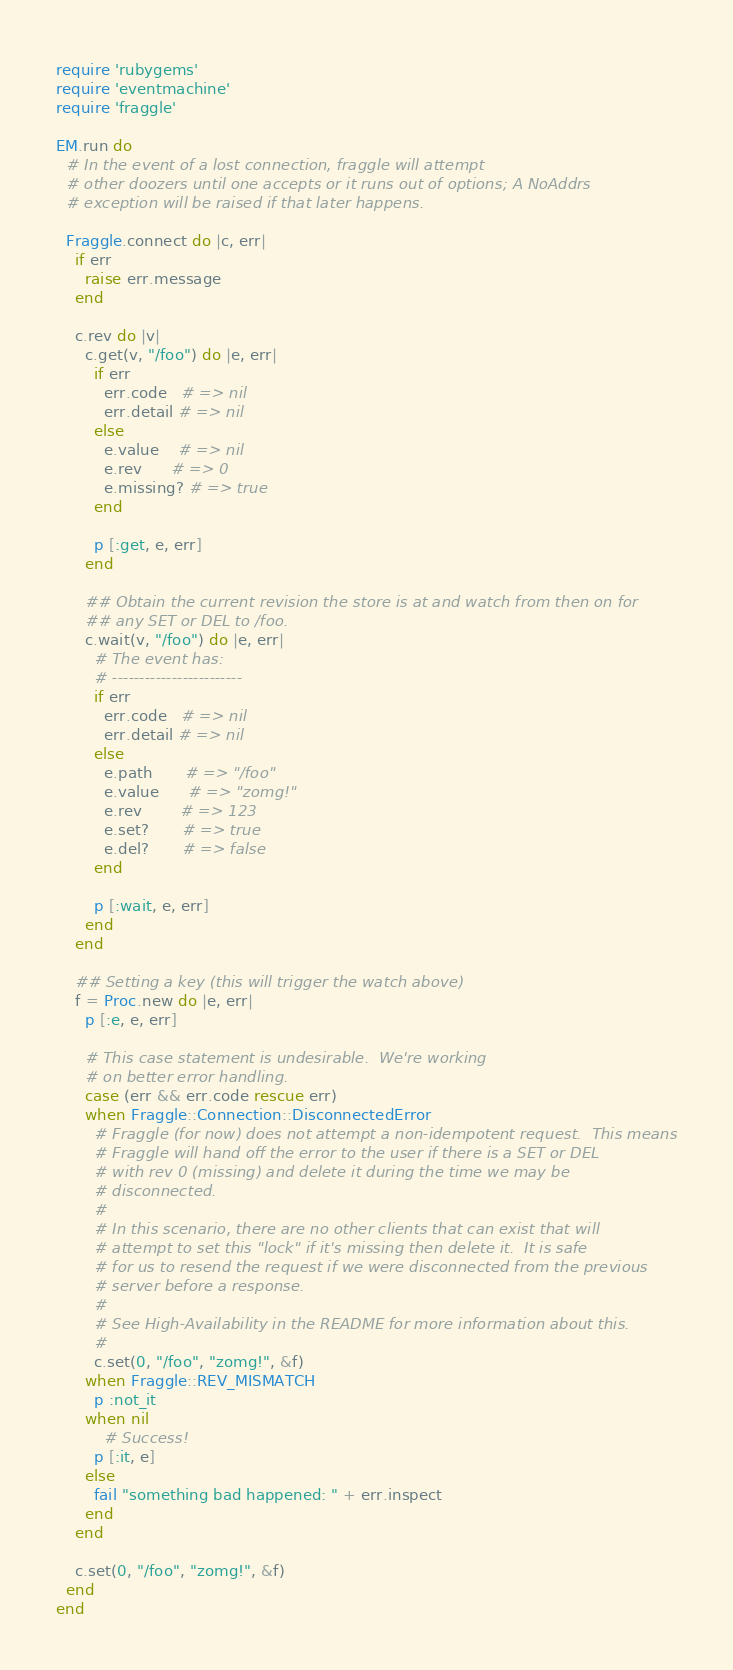<code> <loc_0><loc_0><loc_500><loc_500><_Ruby_>require 'rubygems'
require 'eventmachine'
require 'fraggle'

EM.run do
  # In the event of a lost connection, fraggle will attempt
  # other doozers until one accepts or it runs out of options; A NoAddrs
  # exception will be raised if that later happens.

  Fraggle.connect do |c, err|
    if err
      raise err.message
    end

    c.rev do |v|
      c.get(v, "/foo") do |e, err|
        if err
          err.code   # => nil
          err.detail # => nil
        else
          e.value    # => nil
          e.rev      # => 0
          e.missing? # => true
        end

        p [:get, e, err]
      end

      ## Obtain the current revision the store is at and watch from then on for
      ## any SET or DEL to /foo.
      c.wait(v, "/foo") do |e, err|
        # The event has:
        # ------------------------
        if err
          err.code   # => nil
          err.detail # => nil
        else
          e.path       # => "/foo"
          e.value      # => "zomg!"
          e.rev        # => 123
          e.set?       # => true
          e.del?       # => false
        end

        p [:wait, e, err]
      end
    end

    ## Setting a key (this will trigger the watch above)
    f = Proc.new do |e, err|
      p [:e, e, err]

      # This case statement is undesirable.  We're working
      # on better error handling.
      case (err && err.code rescue err)
      when Fraggle::Connection::DisconnectedError
        # Fraggle (for now) does not attempt a non-idempotent request.  This means
        # Fraggle will hand off the error to the user if there is a SET or DEL
        # with rev 0 (missing) and delete it during the time we may be
        # disconnected.
        #
        # In this scenario, there are no other clients that can exist that will
        # attempt to set this "lock" if it's missing then delete it.  It is safe
        # for us to resend the request if we were disconnected from the previous
        # server before a response.
        #
        # See High-Availability in the README for more information about this.
        #
        c.set(0, "/foo", "zomg!", &f)
      when Fraggle::REV_MISMATCH
        p :not_it
      when nil
          # Success!
        p [:it, e]
      else
        fail "something bad happened: " + err.inspect
      end
    end

    c.set(0, "/foo", "zomg!", &f)
  end
end
</code> 